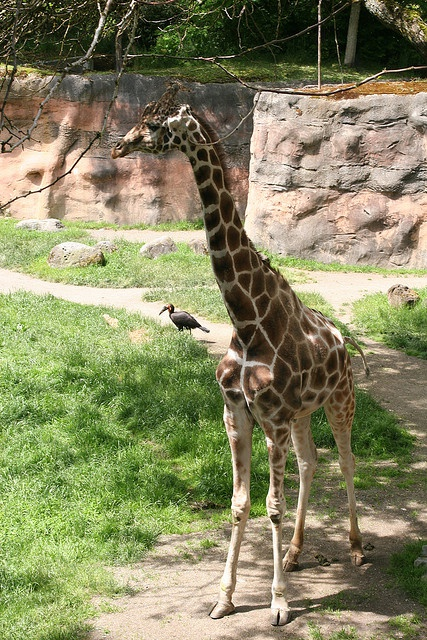Describe the objects in this image and their specific colors. I can see giraffe in black and gray tones and bird in black, gray, darkgray, and ivory tones in this image. 